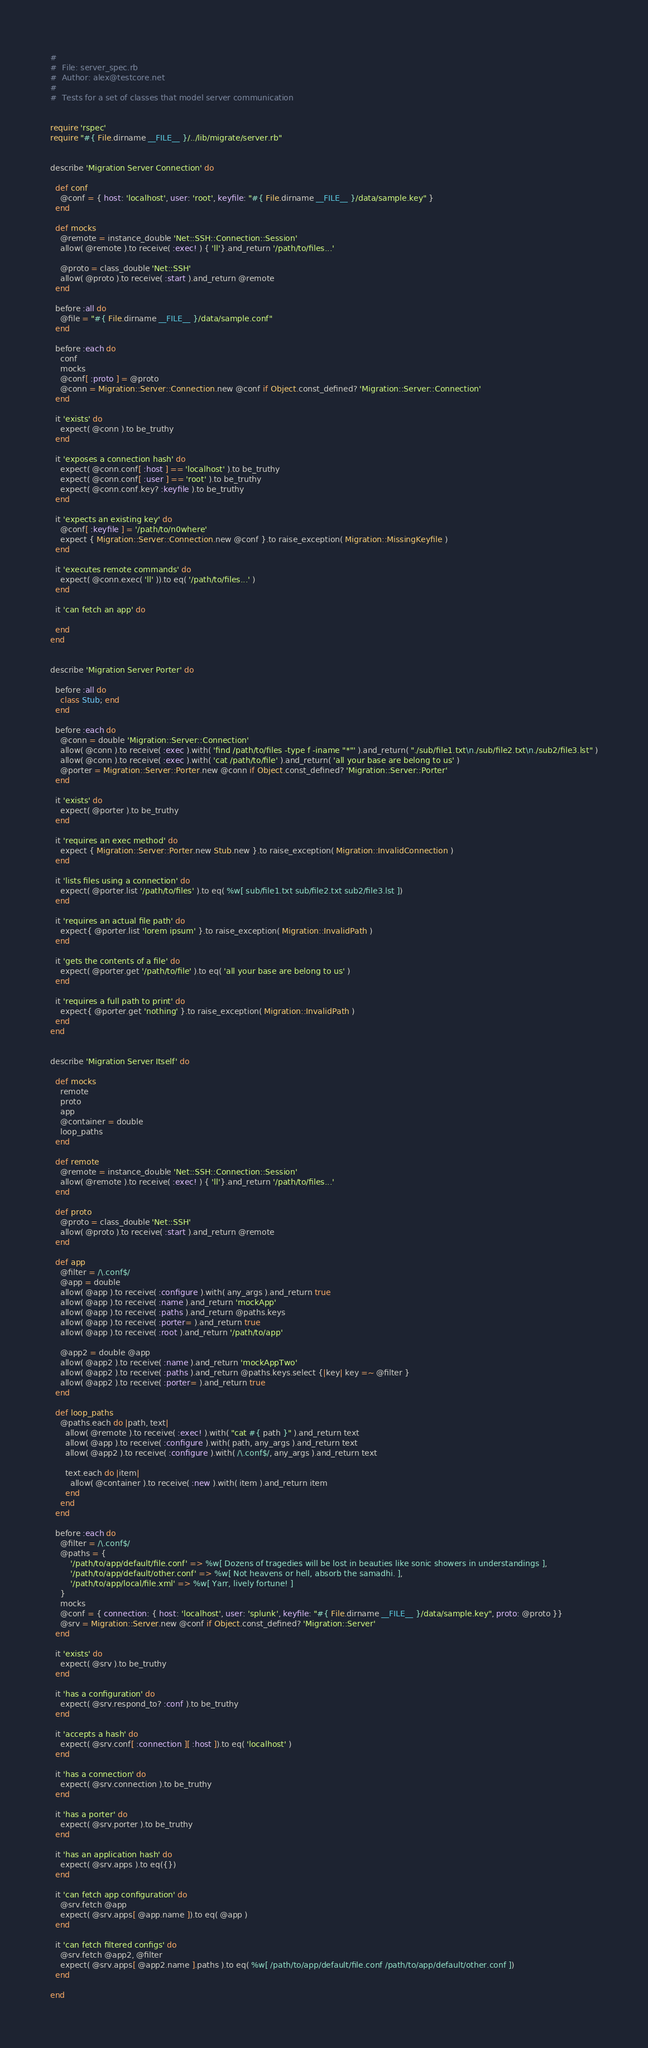<code> <loc_0><loc_0><loc_500><loc_500><_Ruby_>#
#  File: server_spec.rb
#  Author: alex@testcore.net
#
#  Tests for a set of classes that model server communication


require 'rspec'
require "#{ File.dirname __FILE__ }/../lib/migrate/server.rb"


describe 'Migration Server Connection' do

  def conf
    @conf = { host: 'localhost', user: 'root', keyfile: "#{ File.dirname __FILE__ }/data/sample.key" }
  end

  def mocks
    @remote = instance_double 'Net::SSH::Connection::Session'
    allow( @remote ).to receive( :exec! ) { 'll'}.and_return '/path/to/files...'

    @proto = class_double 'Net::SSH'
    allow( @proto ).to receive( :start ).and_return @remote
  end

  before :all do
    @file = "#{ File.dirname __FILE__ }/data/sample.conf"
  end

  before :each do
    conf
    mocks
    @conf[ :proto ] = @proto
    @conn = Migration::Server::Connection.new @conf if Object.const_defined? 'Migration::Server::Connection'
  end

  it 'exists' do
    expect( @conn ).to be_truthy
  end

  it 'exposes a connection hash' do
    expect( @conn.conf[ :host ] == 'localhost' ).to be_truthy
    expect( @conn.conf[ :user ] == 'root' ).to be_truthy
    expect( @conn.conf.key? :keyfile ).to be_truthy
  end

  it 'expects an existing key' do
    @conf[ :keyfile ] = '/path/to/n0where'
    expect { Migration::Server::Connection.new @conf }.to raise_exception( Migration::MissingKeyfile )
  end

  it 'executes remote commands' do
    expect( @conn.exec( 'll' )).to eq( '/path/to/files...' )
  end

  it 'can fetch an app' do

  end
end


describe 'Migration Server Porter' do

  before :all do
    class Stub; end
  end

  before :each do
    @conn = double 'Migration::Server::Connection'
    allow( @conn ).to receive( :exec ).with( 'find /path/to/files -type f -iname "*"' ).and_return( "./sub/file1.txt\n./sub/file2.txt\n./sub2/file3.lst" )
    allow( @conn ).to receive( :exec ).with( 'cat /path/to/file' ).and_return( 'all your base are belong to us' )
    @porter = Migration::Server::Porter.new @conn if Object.const_defined? 'Migration::Server::Porter'
  end

  it 'exists' do
    expect( @porter ).to be_truthy
  end

  it 'requires an exec method' do
    expect { Migration::Server::Porter.new Stub.new }.to raise_exception( Migration::InvalidConnection )
  end

  it 'lists files using a connection' do
    expect( @porter.list '/path/to/files' ).to eq( %w[ sub/file1.txt sub/file2.txt sub2/file3.lst ])
  end

  it 'requires an actual file path' do
    expect{ @porter.list 'lorem ipsum' }.to raise_exception( Migration::InvalidPath )
  end

  it 'gets the contents of a file' do
    expect( @porter.get '/path/to/file' ).to eq( 'all your base are belong to us' )
  end

  it 'requires a full path to print' do
    expect{ @porter.get 'nothing' }.to raise_exception( Migration::InvalidPath )
  end
end


describe 'Migration Server Itself' do

  def mocks
    remote
    proto
    app
    @container = double
    loop_paths
  end

  def remote
    @remote = instance_double 'Net::SSH::Connection::Session'
    allow( @remote ).to receive( :exec! ) { 'll'}.and_return '/path/to/files...'
  end

  def proto
    @proto = class_double 'Net::SSH'
    allow( @proto ).to receive( :start ).and_return @remote
  end

  def app
    @filter = /\.conf$/
    @app = double
    allow( @app ).to receive( :configure ).with( any_args ).and_return true
    allow( @app ).to receive( :name ).and_return 'mockApp'
    allow( @app ).to receive( :paths ).and_return @paths.keys
    allow( @app ).to receive( :porter= ).and_return true
    allow( @app ).to receive( :root ).and_return '/path/to/app'

    @app2 = double @app
    allow( @app2 ).to receive( :name ).and_return 'mockAppTwo'
    allow( @app2 ).to receive( :paths ).and_return @paths.keys.select {|key| key =~ @filter }
    allow( @app2 ).to receive( :porter= ).and_return true
  end

  def loop_paths
    @paths.each do |path, text|
      allow( @remote ).to receive( :exec! ).with( "cat #{ path }" ).and_return text
      allow( @app ).to receive( :configure ).with( path, any_args ).and_return text
      allow( @app2 ).to receive( :configure ).with( /\.conf$/, any_args ).and_return text

      text.each do |item|
        allow( @container ).to receive( :new ).with( item ).and_return item
      end
    end
  end

  before :each do
    @filter = /\.conf$/
    @paths = {
        '/path/to/app/default/file.conf' => %w[ Dozens of tragedies will be lost in beauties like sonic showers in understandings ],
        '/path/to/app/default/other.conf' => %w[ Not heavens or hell, absorb the samadhi. ],
        '/path/to/app/local/file.xml' => %w[ Yarr, lively fortune! ]
    }
    mocks
    @conf = { connection: { host: 'localhost', user: 'splunk', keyfile: "#{ File.dirname __FILE__ }/data/sample.key", proto: @proto }}
    @srv = Migration::Server.new @conf if Object.const_defined? 'Migration::Server'
  end

  it 'exists' do
    expect( @srv ).to be_truthy
  end

  it 'has a configuration' do
    expect( @srv.respond_to? :conf ).to be_truthy
  end

  it 'accepts a hash' do
    expect( @srv.conf[ :connection ][ :host ]).to eq( 'localhost' )
  end

  it 'has a connection' do
    expect( @srv.connection ).to be_truthy
  end

  it 'has a porter' do
    expect( @srv.porter ).to be_truthy
  end

  it 'has an application hash' do
    expect( @srv.apps ).to eq({})
  end

  it 'can fetch app configuration' do
    @srv.fetch @app
    expect( @srv.apps[ @app.name ]).to eq( @app )
  end

  it 'can fetch filtered configs' do
    @srv.fetch @app2, @filter
    expect( @srv.apps[ @app2.name ].paths ).to eq( %w[ /path/to/app/default/file.conf /path/to/app/default/other.conf ])
  end

end
</code> 